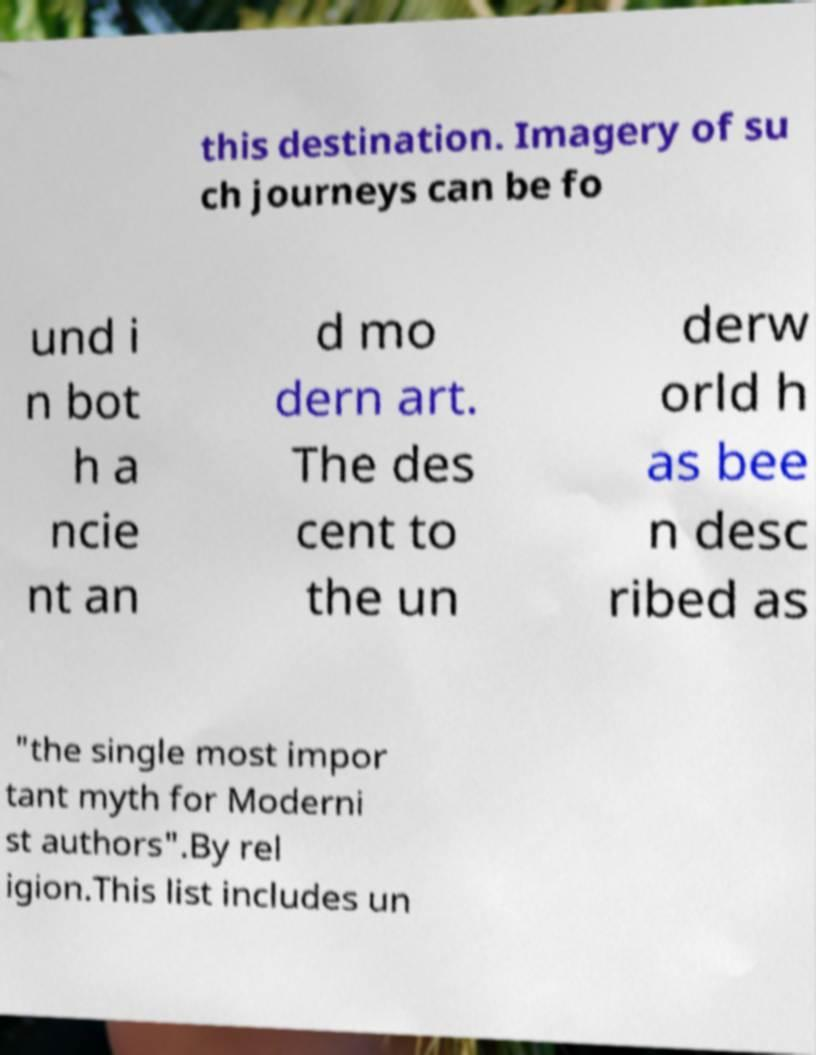Please identify and transcribe the text found in this image. this destination. Imagery of su ch journeys can be fo und i n bot h a ncie nt an d mo dern art. The des cent to the un derw orld h as bee n desc ribed as "the single most impor tant myth for Moderni st authors".By rel igion.This list includes un 